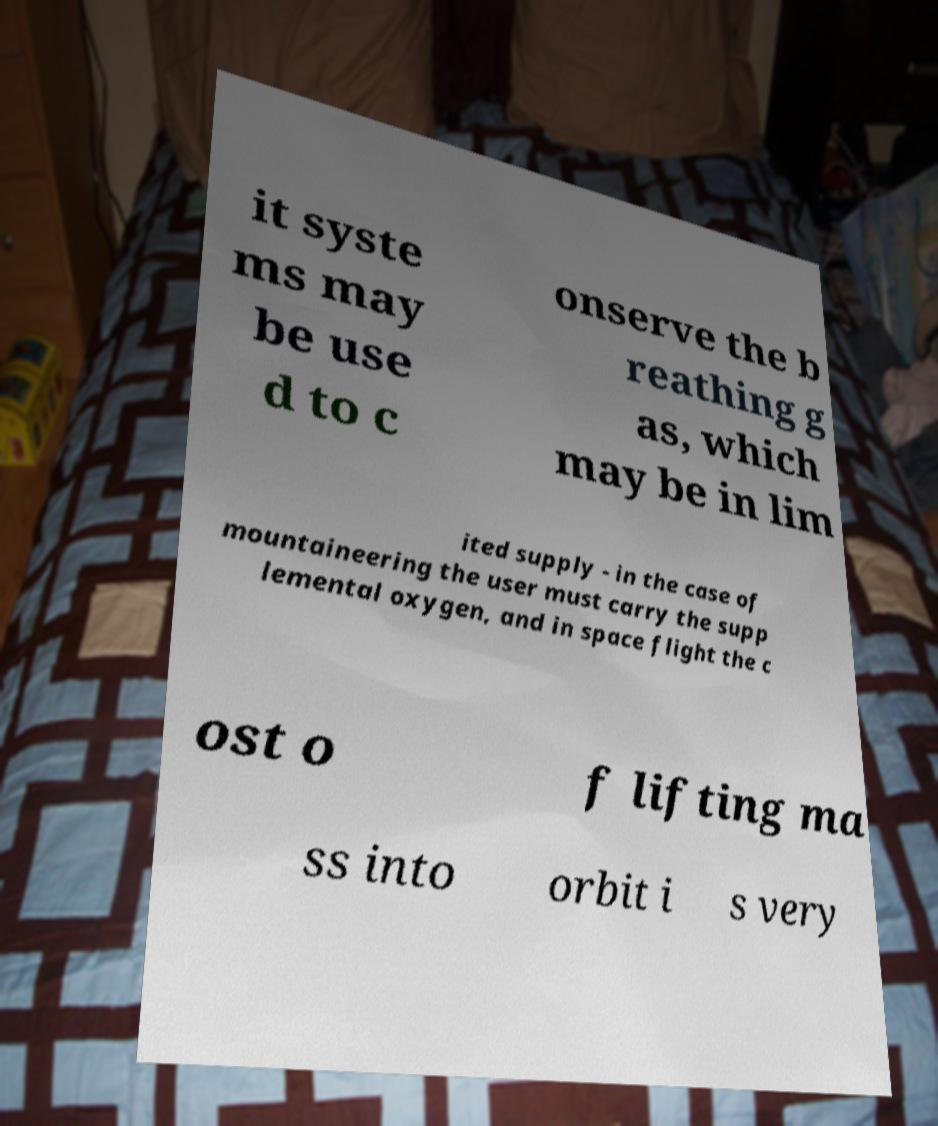Could you extract and type out the text from this image? it syste ms may be use d to c onserve the b reathing g as, which may be in lim ited supply - in the case of mountaineering the user must carry the supp lemental oxygen, and in space flight the c ost o f lifting ma ss into orbit i s very 